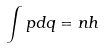<formula> <loc_0><loc_0><loc_500><loc_500>\int p d q = n h</formula> 